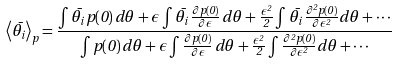<formula> <loc_0><loc_0><loc_500><loc_500>\left \langle \bar { \theta } _ { i } \right \rangle _ { p } = \frac { \int \bar { \theta } _ { i } \, p ( 0 ) \, d \theta + \epsilon \int \bar { \theta } _ { i } \, \frac { \partial p ( 0 ) } { \partial \epsilon } \, d \theta + \frac { \epsilon ^ { 2 } } { 2 } \int \bar { \theta } _ { i } \, \frac { \partial ^ { 2 } p ( 0 ) } { \partial \epsilon ^ { 2 } } d \theta + \cdots } { \int p ( 0 ) \, d \theta + \epsilon \int \frac { \partial p ( 0 ) } { \partial \epsilon } \, d \theta + \frac { \epsilon ^ { 2 } } { 2 } \int \frac { \partial ^ { 2 } p ( 0 ) } { \partial \epsilon ^ { 2 } } d \theta + \cdots }</formula> 